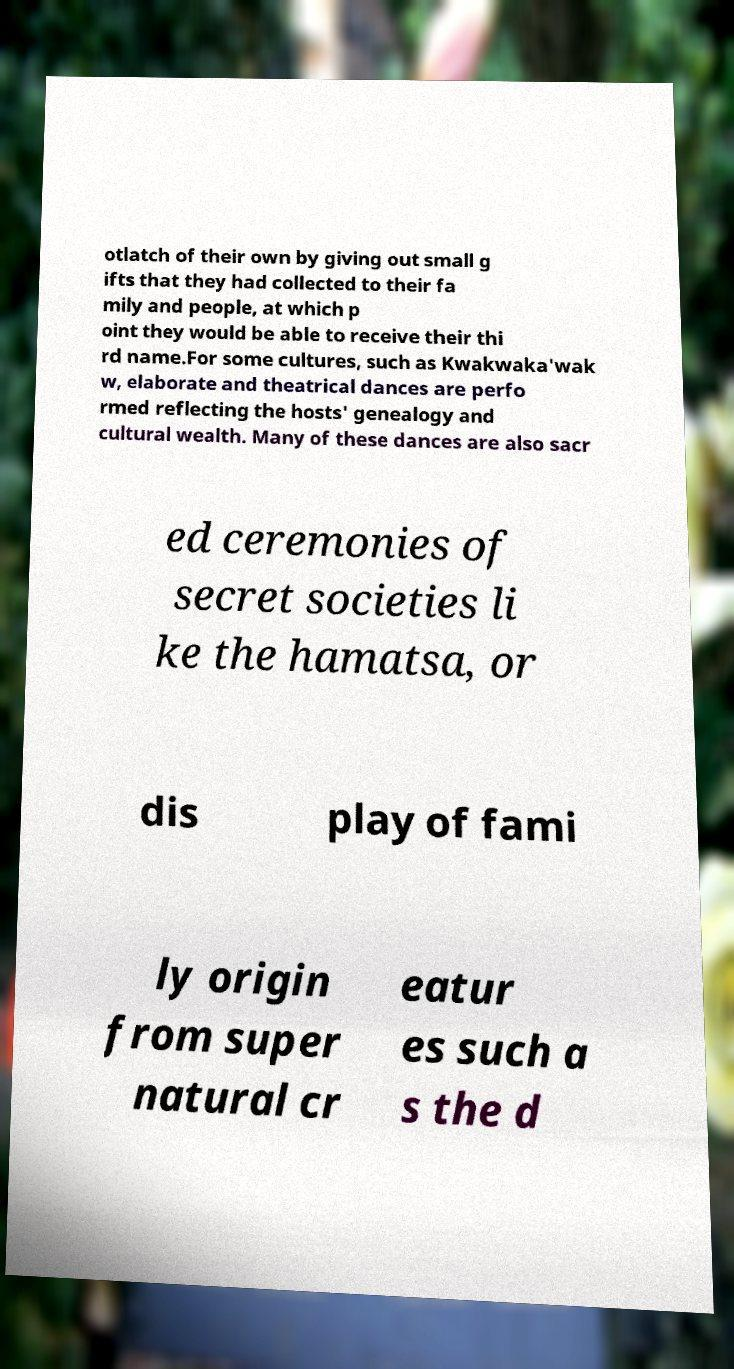Could you assist in decoding the text presented in this image and type it out clearly? otlatch of their own by giving out small g ifts that they had collected to their fa mily and people, at which p oint they would be able to receive their thi rd name.For some cultures, such as Kwakwaka'wak w, elaborate and theatrical dances are perfo rmed reflecting the hosts' genealogy and cultural wealth. Many of these dances are also sacr ed ceremonies of secret societies li ke the hamatsa, or dis play of fami ly origin from super natural cr eatur es such a s the d 